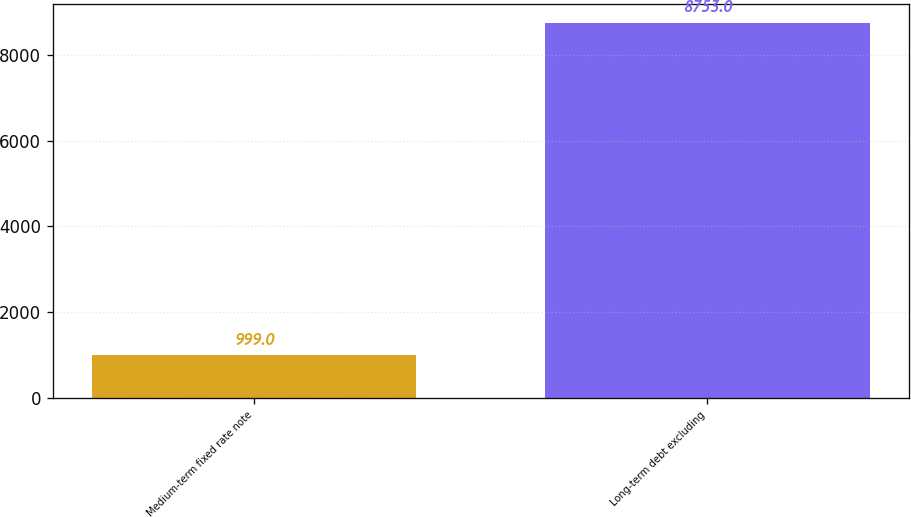Convert chart to OTSL. <chart><loc_0><loc_0><loc_500><loc_500><bar_chart><fcel>Medium-term fixed rate note<fcel>Long-term debt excluding<nl><fcel>999<fcel>8753<nl></chart> 